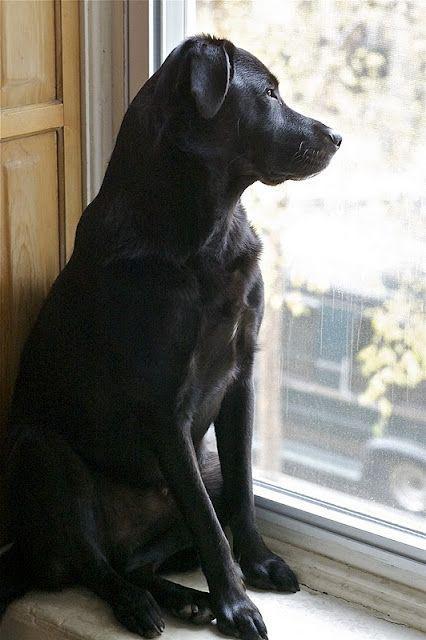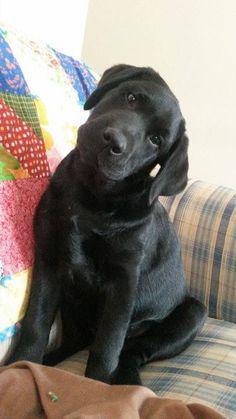The first image is the image on the left, the second image is the image on the right. For the images shown, is this caption "The left image contains no more than one dog." true? Answer yes or no. Yes. The first image is the image on the left, the second image is the image on the right. Given the left and right images, does the statement "An image featuring reclining labrador retrievers includes one """"blond"""" dog." hold true? Answer yes or no. No. 